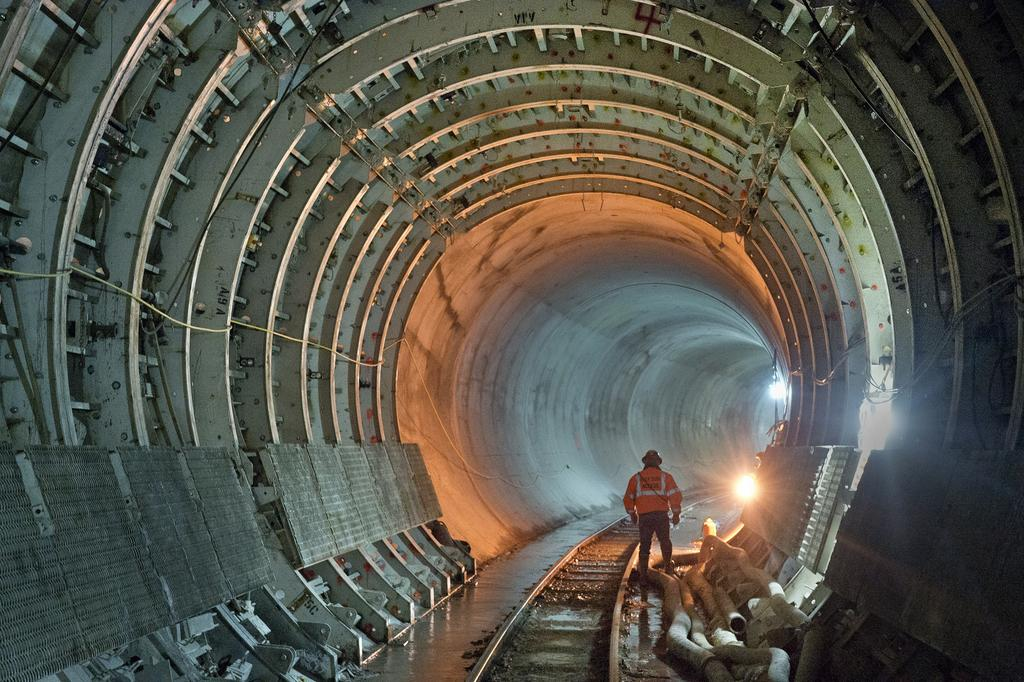What type of infrastructure is present in the image? There is an underground railway track in the image. Can you describe the person in the image? There is a person standing in the image. What else can be seen in the image besides the railway track and the person? There are pipes and a light visible in the image. What might be the purpose of the unspecified objects in the image? The unspecified objects could be related to the railway infrastructure or other utilities. What is the person's opinion on the comfort of the underground railway system in the image? The image does not provide any information about the person's opinion, nor does it show any details about the comfort of the underground railway system. 